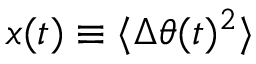<formula> <loc_0><loc_0><loc_500><loc_500>x ( t ) \equiv \langle \Delta \theta ( t ) ^ { 2 } \rangle</formula> 